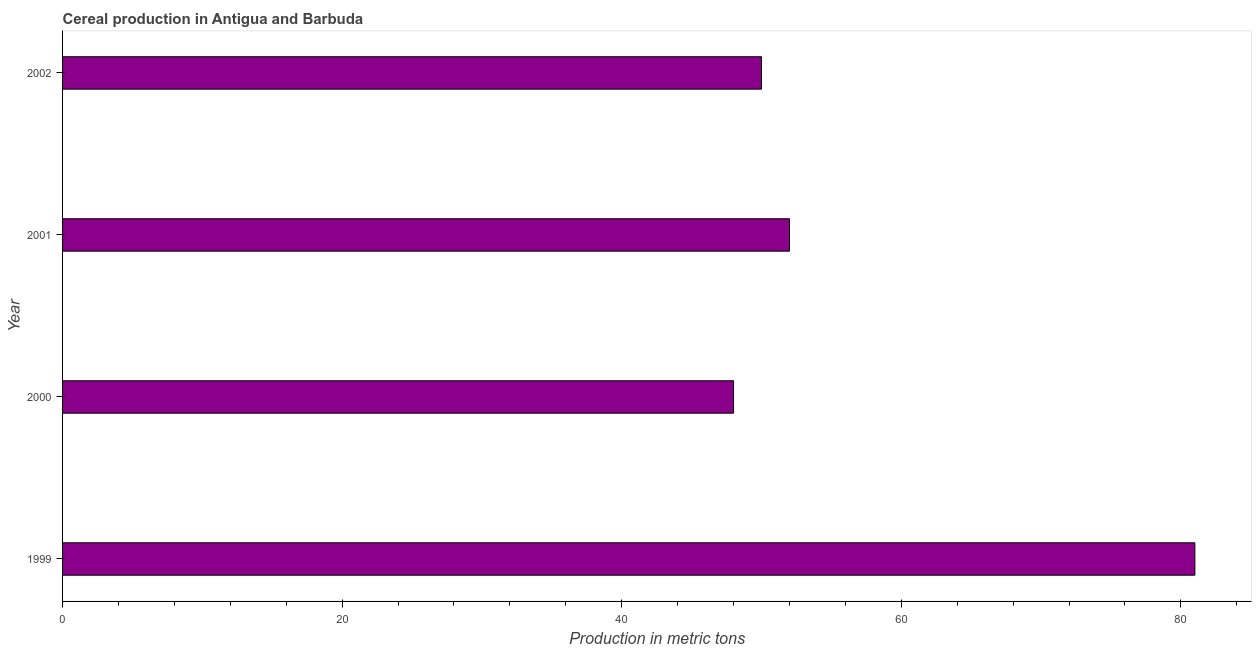Does the graph contain any zero values?
Give a very brief answer. No. Does the graph contain grids?
Your response must be concise. No. What is the title of the graph?
Make the answer very short. Cereal production in Antigua and Barbuda. What is the label or title of the X-axis?
Provide a succinct answer. Production in metric tons. What is the label or title of the Y-axis?
Keep it short and to the point. Year. What is the cereal production in 1999?
Give a very brief answer. 81. Across all years, what is the maximum cereal production?
Your response must be concise. 81. Across all years, what is the minimum cereal production?
Make the answer very short. 48. In which year was the cereal production minimum?
Ensure brevity in your answer.  2000. What is the sum of the cereal production?
Ensure brevity in your answer.  231. What is the difference between the cereal production in 2000 and 2002?
Provide a short and direct response. -2. What is the average cereal production per year?
Make the answer very short. 57. In how many years, is the cereal production greater than 4 metric tons?
Offer a terse response. 4. What is the ratio of the cereal production in 2001 to that in 2002?
Provide a succinct answer. 1.04. Is the cereal production in 2000 less than that in 2002?
Ensure brevity in your answer.  Yes. What is the difference between the highest and the second highest cereal production?
Offer a very short reply. 29. Is the sum of the cereal production in 2000 and 2001 greater than the maximum cereal production across all years?
Make the answer very short. Yes. What is the difference between the highest and the lowest cereal production?
Offer a very short reply. 33. In how many years, is the cereal production greater than the average cereal production taken over all years?
Make the answer very short. 1. Are all the bars in the graph horizontal?
Give a very brief answer. Yes. What is the difference between two consecutive major ticks on the X-axis?
Keep it short and to the point. 20. Are the values on the major ticks of X-axis written in scientific E-notation?
Provide a short and direct response. No. What is the Production in metric tons of 1999?
Keep it short and to the point. 81. What is the Production in metric tons of 2000?
Your answer should be very brief. 48. What is the Production in metric tons in 2002?
Offer a terse response. 50. What is the difference between the Production in metric tons in 1999 and 2000?
Your answer should be very brief. 33. What is the difference between the Production in metric tons in 1999 and 2002?
Give a very brief answer. 31. What is the difference between the Production in metric tons in 2000 and 2001?
Offer a terse response. -4. What is the difference between the Production in metric tons in 2000 and 2002?
Offer a terse response. -2. What is the ratio of the Production in metric tons in 1999 to that in 2000?
Offer a very short reply. 1.69. What is the ratio of the Production in metric tons in 1999 to that in 2001?
Make the answer very short. 1.56. What is the ratio of the Production in metric tons in 1999 to that in 2002?
Provide a succinct answer. 1.62. What is the ratio of the Production in metric tons in 2000 to that in 2001?
Offer a terse response. 0.92. 